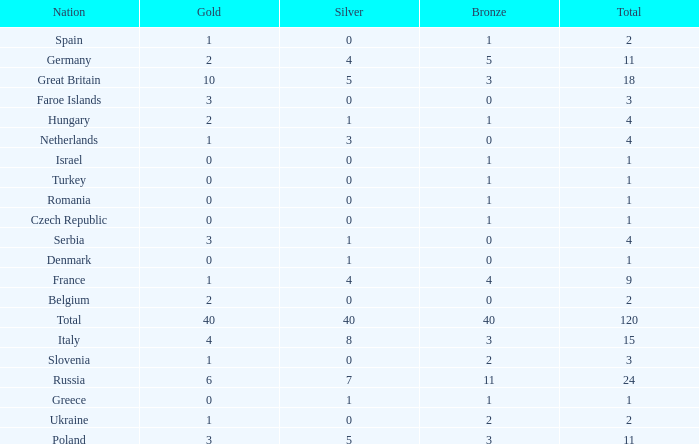What Nation has a Gold entry that is greater than 0, a Total that is greater than 2, a Silver entry that is larger than 1, and 0 Bronze? Netherlands. 